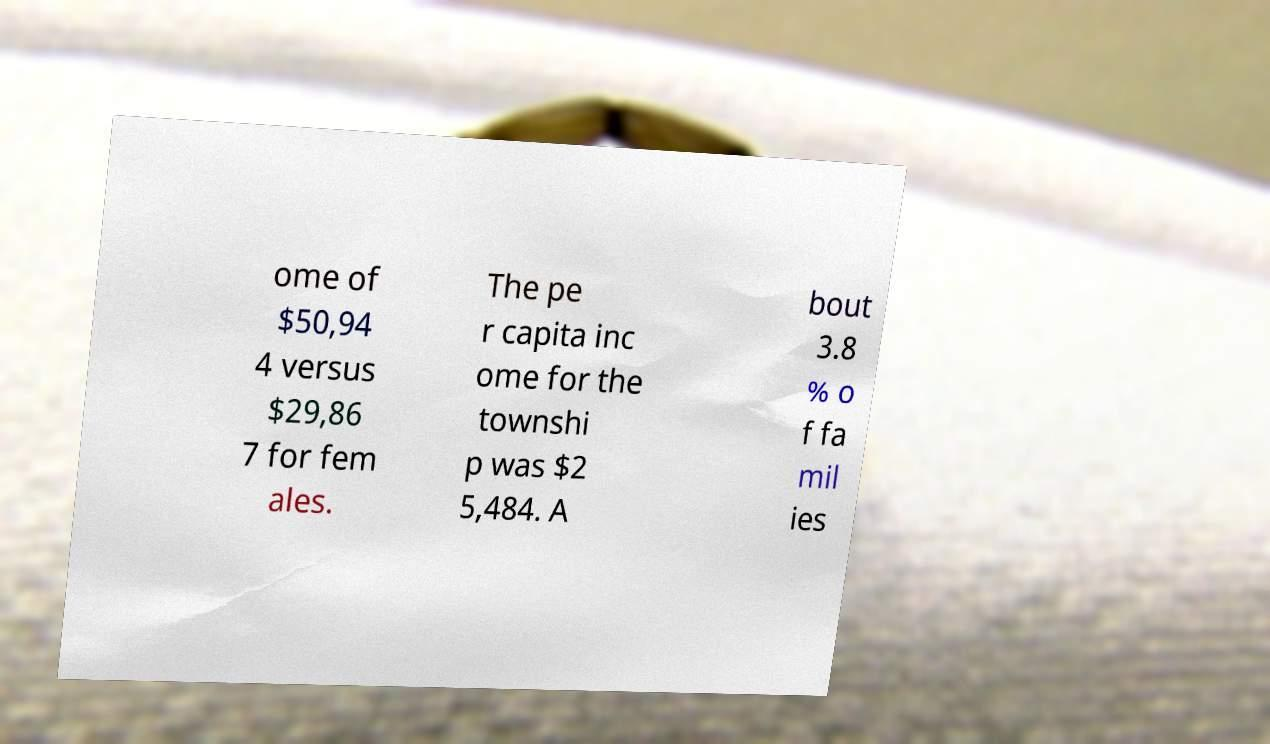Can you accurately transcribe the text from the provided image for me? ome of $50,94 4 versus $29,86 7 for fem ales. The pe r capita inc ome for the townshi p was $2 5,484. A bout 3.8 % o f fa mil ies 